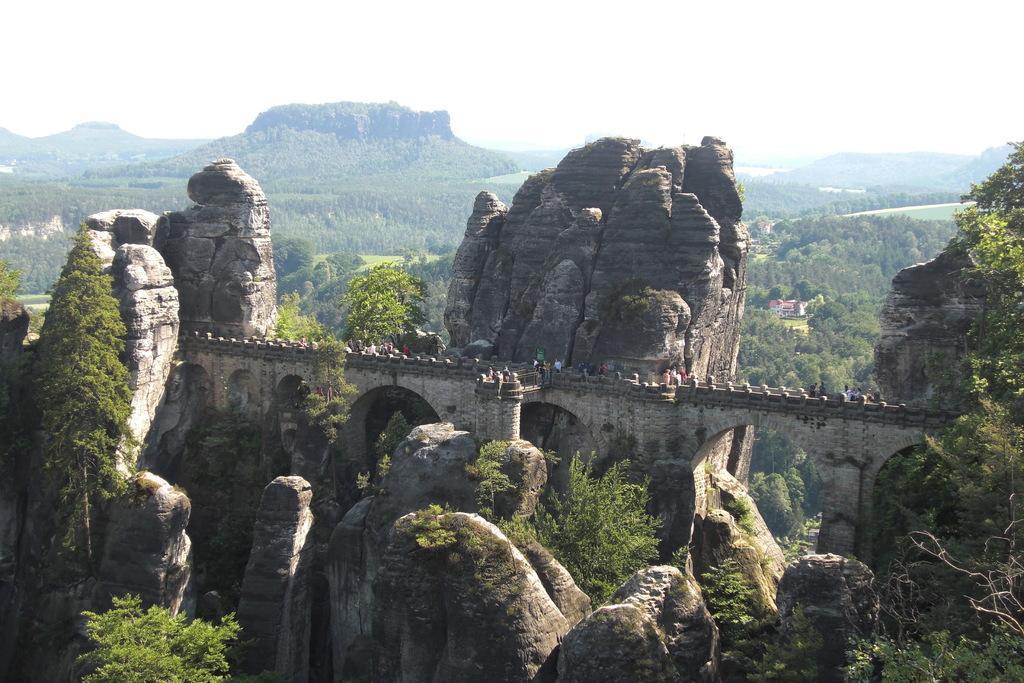How would you summarize this image in a sentence or two? At the bottom of the picture, we see the trees and the rocks. In the middle, we see a bridge and the people are standing. We see a castle and beside that, we see the rocks. There are trees and the hills in the background. At the top, we see the sky. 